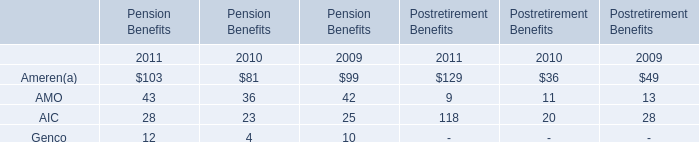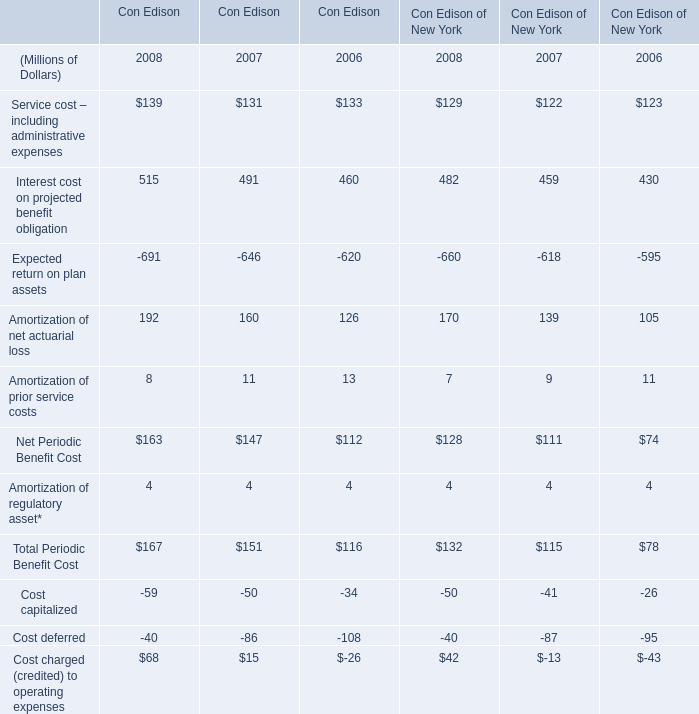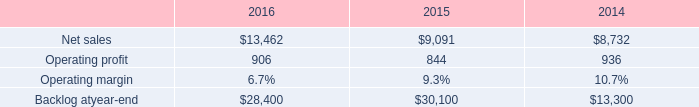When does Service cost – including administrative expenses in Con Edison reach the largest value? 
Answer: 2008. 